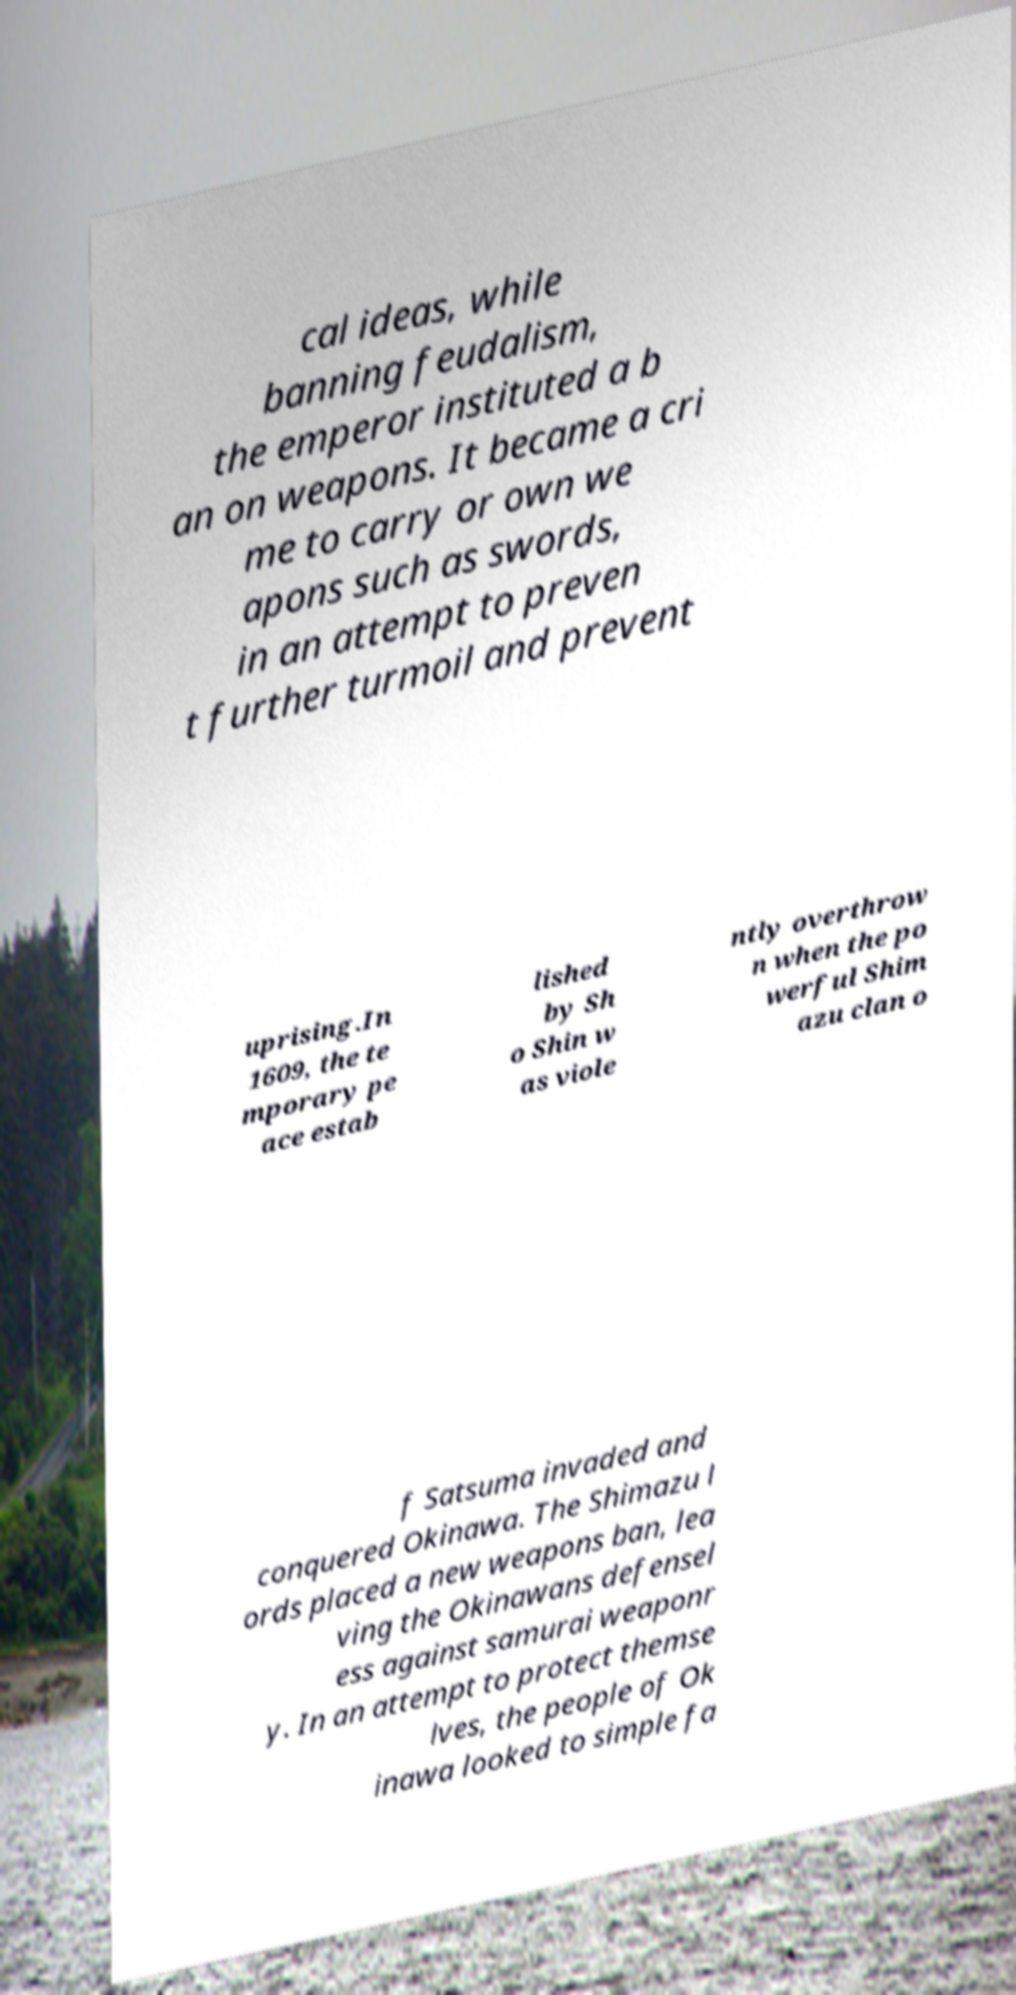Please identify and transcribe the text found in this image. cal ideas, while banning feudalism, the emperor instituted a b an on weapons. It became a cri me to carry or own we apons such as swords, in an attempt to preven t further turmoil and prevent uprising.In 1609, the te mporary pe ace estab lished by Sh o Shin w as viole ntly overthrow n when the po werful Shim azu clan o f Satsuma invaded and conquered Okinawa. The Shimazu l ords placed a new weapons ban, lea ving the Okinawans defensel ess against samurai weaponr y. In an attempt to protect themse lves, the people of Ok inawa looked to simple fa 